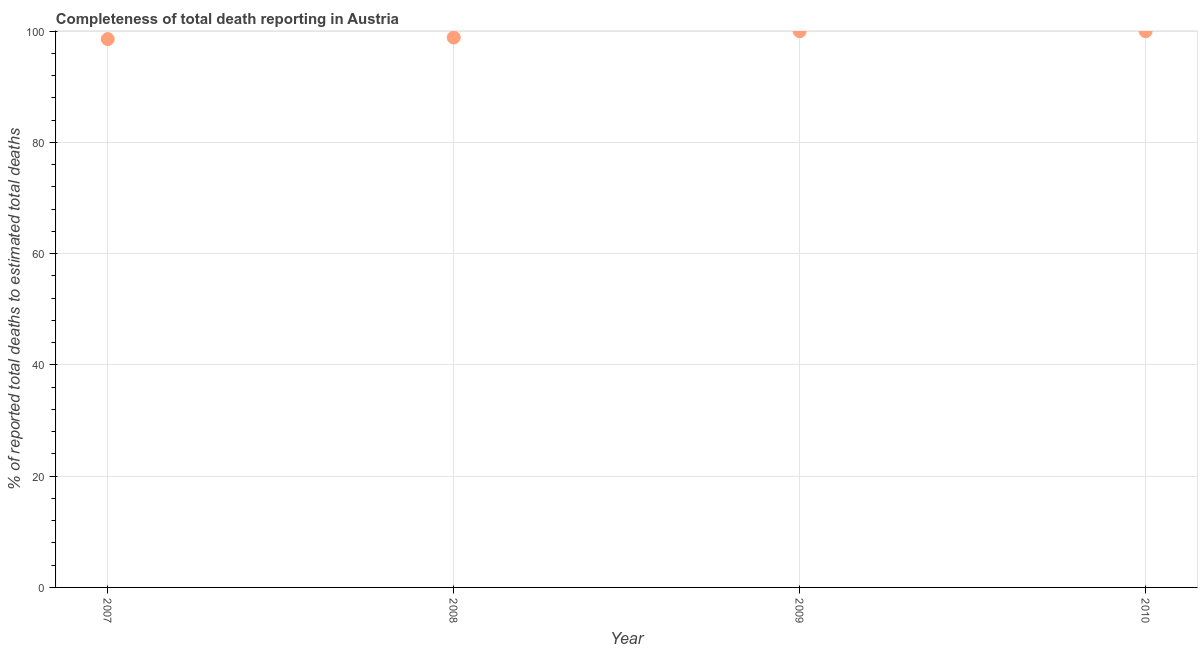What is the completeness of total death reports in 2009?
Keep it short and to the point. 100. Across all years, what is the minimum completeness of total death reports?
Your response must be concise. 98.58. What is the sum of the completeness of total death reports?
Make the answer very short. 397.44. What is the difference between the completeness of total death reports in 2007 and 2008?
Your answer should be very brief. -0.28. What is the average completeness of total death reports per year?
Keep it short and to the point. 99.36. What is the median completeness of total death reports?
Provide a short and direct response. 99.43. Is the difference between the completeness of total death reports in 2007 and 2009 greater than the difference between any two years?
Offer a terse response. Yes. What is the difference between the highest and the second highest completeness of total death reports?
Your response must be concise. 0. Is the sum of the completeness of total death reports in 2007 and 2008 greater than the maximum completeness of total death reports across all years?
Offer a terse response. Yes. What is the difference between the highest and the lowest completeness of total death reports?
Provide a short and direct response. 1.42. Does the completeness of total death reports monotonically increase over the years?
Provide a short and direct response. No. How many years are there in the graph?
Your answer should be compact. 4. Are the values on the major ticks of Y-axis written in scientific E-notation?
Offer a very short reply. No. Does the graph contain grids?
Keep it short and to the point. Yes. What is the title of the graph?
Give a very brief answer. Completeness of total death reporting in Austria. What is the label or title of the Y-axis?
Keep it short and to the point. % of reported total deaths to estimated total deaths. What is the % of reported total deaths to estimated total deaths in 2007?
Offer a terse response. 98.58. What is the % of reported total deaths to estimated total deaths in 2008?
Ensure brevity in your answer.  98.86. What is the % of reported total deaths to estimated total deaths in 2009?
Make the answer very short. 100. What is the difference between the % of reported total deaths to estimated total deaths in 2007 and 2008?
Offer a terse response. -0.28. What is the difference between the % of reported total deaths to estimated total deaths in 2007 and 2009?
Offer a very short reply. -1.42. What is the difference between the % of reported total deaths to estimated total deaths in 2007 and 2010?
Ensure brevity in your answer.  -1.42. What is the difference between the % of reported total deaths to estimated total deaths in 2008 and 2009?
Offer a terse response. -1.14. What is the difference between the % of reported total deaths to estimated total deaths in 2008 and 2010?
Your answer should be compact. -1.14. What is the ratio of the % of reported total deaths to estimated total deaths in 2007 to that in 2009?
Your answer should be compact. 0.99. What is the ratio of the % of reported total deaths to estimated total deaths in 2009 to that in 2010?
Give a very brief answer. 1. 